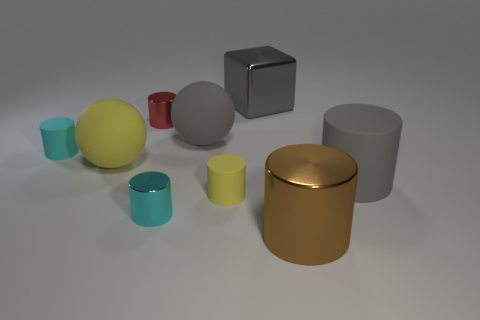Subtract all big gray cylinders. How many cylinders are left? 5 Add 1 tiny cylinders. How many objects exist? 10 Subtract all red cylinders. How many cylinders are left? 5 Subtract 1 cylinders. How many cylinders are left? 5 Subtract all cylinders. How many objects are left? 3 Subtract all gray spheres. How many blue cylinders are left? 0 Subtract all large cyan matte cylinders. Subtract all red metallic things. How many objects are left? 8 Add 8 large matte cylinders. How many large matte cylinders are left? 9 Add 9 large brown things. How many large brown things exist? 10 Subtract 1 gray spheres. How many objects are left? 8 